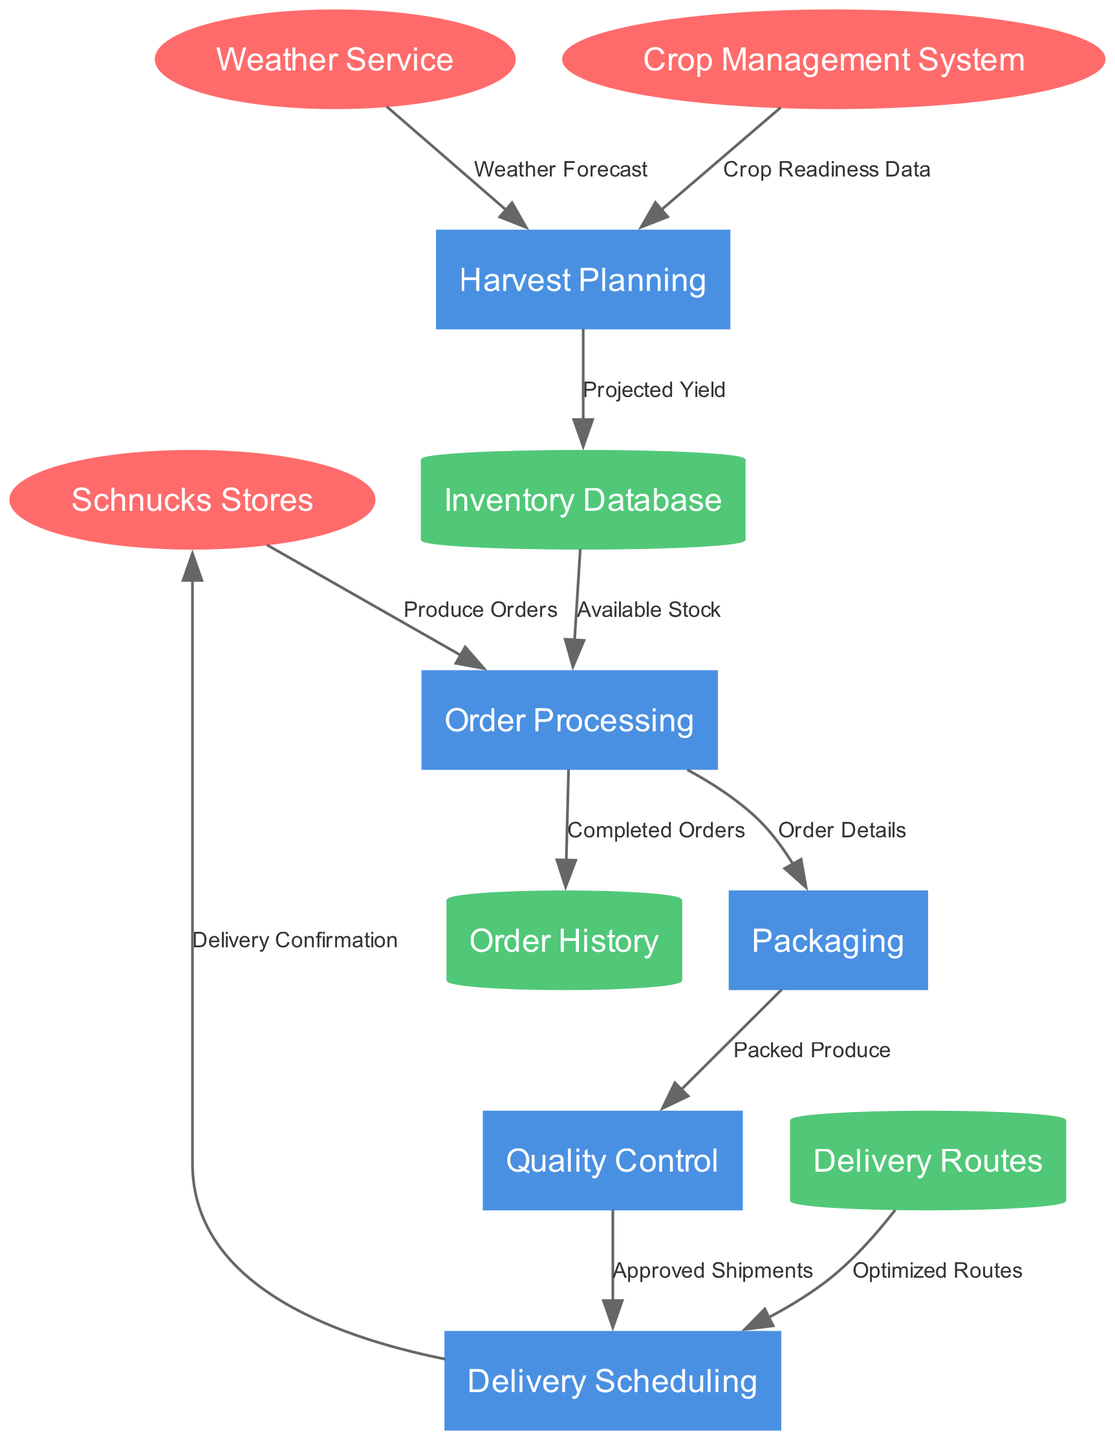What are the external entities in the diagram? The diagram includes three external entities: Schnucks Stores, Weather Service, and Crop Management System. These entities represent the sources or consumers of data in the system.
Answer: Schnucks Stores, Weather Service, Crop Management System How many processes are involved in the order fulfillment system? The diagram lists five processes that are involved in the order fulfillment system: Harvest Planning, Quality Control, Order Processing, Packaging, and Delivery Scheduling.
Answer: Five What is the output of the Order Processing process? The Order Processing process outputs "Order Details" to the Packaging process, indicating the information related to the orders that need to be packaged.
Answer: Order Details Which process receives data from the Quality Control process? The Delivery Scheduling process receives data labeled "Approved Shipments" from the Quality Control process, indicating that only approved shipments are scheduled for delivery.
Answer: Delivery Scheduling What data flows from the Inventory Database to Order Processing? The data that flows from the Inventory Database to Order Processing is labeled "Available Stock". This indicates that Order Processing accesses the current stock information to fulfill orders.
Answer: Available Stock How many data stores are present in the diagram? There are three data stores mentioned in the diagram: Inventory Database, Order History, and Delivery Routes. These stores hold important information in the fulfillment process.
Answer: Three Which external entity provides a weather forecast? The Weather Service is the external entity that provides the "Weather Forecast" to the Harvest Planning process, allowing for better planning based on weather conditions.
Answer: Weather Service What flows from the Delivery Routes data store to Delivery Scheduling? The flow from the Delivery Routes data store to Delivery Scheduling is labeled "Optimized Routes". This represents data that helps in planning delivery routes efficiently.
Answer: Optimized Routes What does the Order Processing process send to the Order History data store? The Order Processing process sends "Completed Orders" to the Order History data store, capturing the details of orders that have been successfully fulfilled.
Answer: Completed Orders 